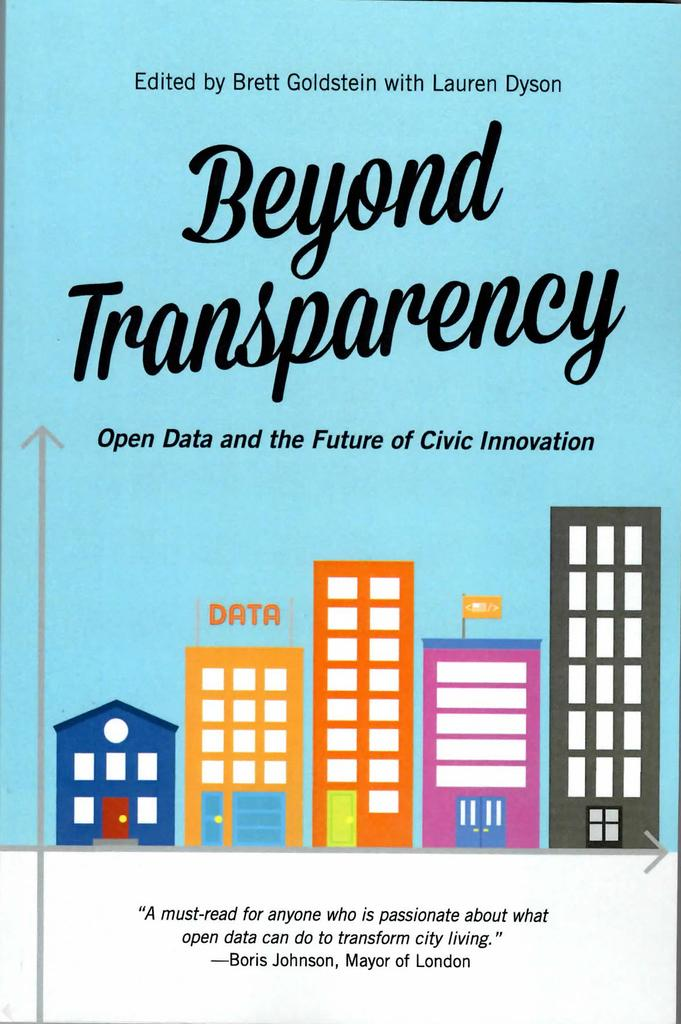Provide a one-sentence caption for the provided image. Beyond Transparency book that is a must read. 